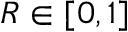<formula> <loc_0><loc_0><loc_500><loc_500>R \in [ 0 , 1 ]</formula> 